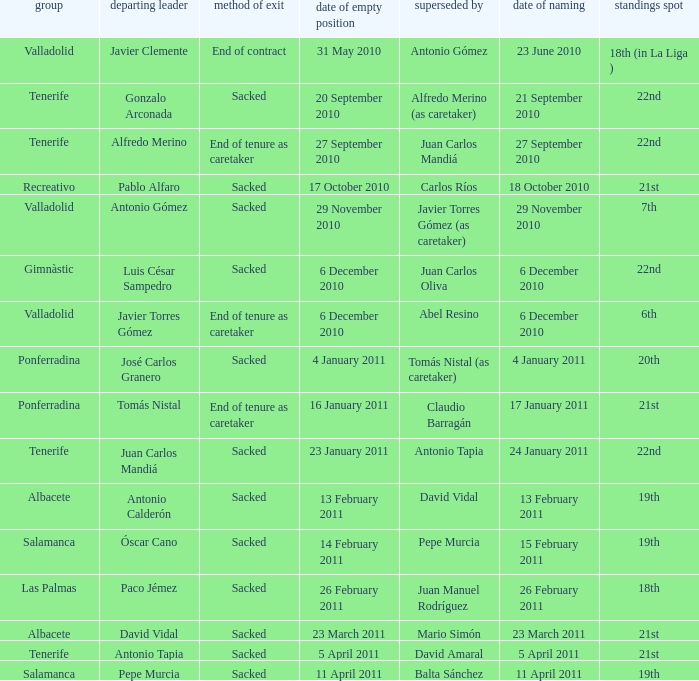Could you help me parse every detail presented in this table? {'header': ['group', 'departing leader', 'method of exit', 'date of empty position', 'superseded by', 'date of naming', 'standings spot'], 'rows': [['Valladolid', 'Javier Clemente', 'End of contract', '31 May 2010', 'Antonio Gómez', '23 June 2010', '18th (in La Liga )'], ['Tenerife', 'Gonzalo Arconada', 'Sacked', '20 September 2010', 'Alfredo Merino (as caretaker)', '21 September 2010', '22nd'], ['Tenerife', 'Alfredo Merino', 'End of tenure as caretaker', '27 September 2010', 'Juan Carlos Mandiá', '27 September 2010', '22nd'], ['Recreativo', 'Pablo Alfaro', 'Sacked', '17 October 2010', 'Carlos Ríos', '18 October 2010', '21st'], ['Valladolid', 'Antonio Gómez', 'Sacked', '29 November 2010', 'Javier Torres Gómez (as caretaker)', '29 November 2010', '7th'], ['Gimnàstic', 'Luis César Sampedro', 'Sacked', '6 December 2010', 'Juan Carlos Oliva', '6 December 2010', '22nd'], ['Valladolid', 'Javier Torres Gómez', 'End of tenure as caretaker', '6 December 2010', 'Abel Resino', '6 December 2010', '6th'], ['Ponferradina', 'José Carlos Granero', 'Sacked', '4 January 2011', 'Tomás Nistal (as caretaker)', '4 January 2011', '20th'], ['Ponferradina', 'Tomás Nistal', 'End of tenure as caretaker', '16 January 2011', 'Claudio Barragán', '17 January 2011', '21st'], ['Tenerife', 'Juan Carlos Mandiá', 'Sacked', '23 January 2011', 'Antonio Tapia', '24 January 2011', '22nd'], ['Albacete', 'Antonio Calderón', 'Sacked', '13 February 2011', 'David Vidal', '13 February 2011', '19th'], ['Salamanca', 'Óscar Cano', 'Sacked', '14 February 2011', 'Pepe Murcia', '15 February 2011', '19th'], ['Las Palmas', 'Paco Jémez', 'Sacked', '26 February 2011', 'Juan Manuel Rodríguez', '26 February 2011', '18th'], ['Albacete', 'David Vidal', 'Sacked', '23 March 2011', 'Mario Simón', '23 March 2011', '21st'], ['Tenerife', 'Antonio Tapia', 'Sacked', '5 April 2011', 'David Amaral', '5 April 2011', '21st'], ['Salamanca', 'Pepe Murcia', 'Sacked', '11 April 2011', 'Balta Sánchez', '11 April 2011', '19th']]} How many teams had an appointment date of 11 april 2011 1.0. 